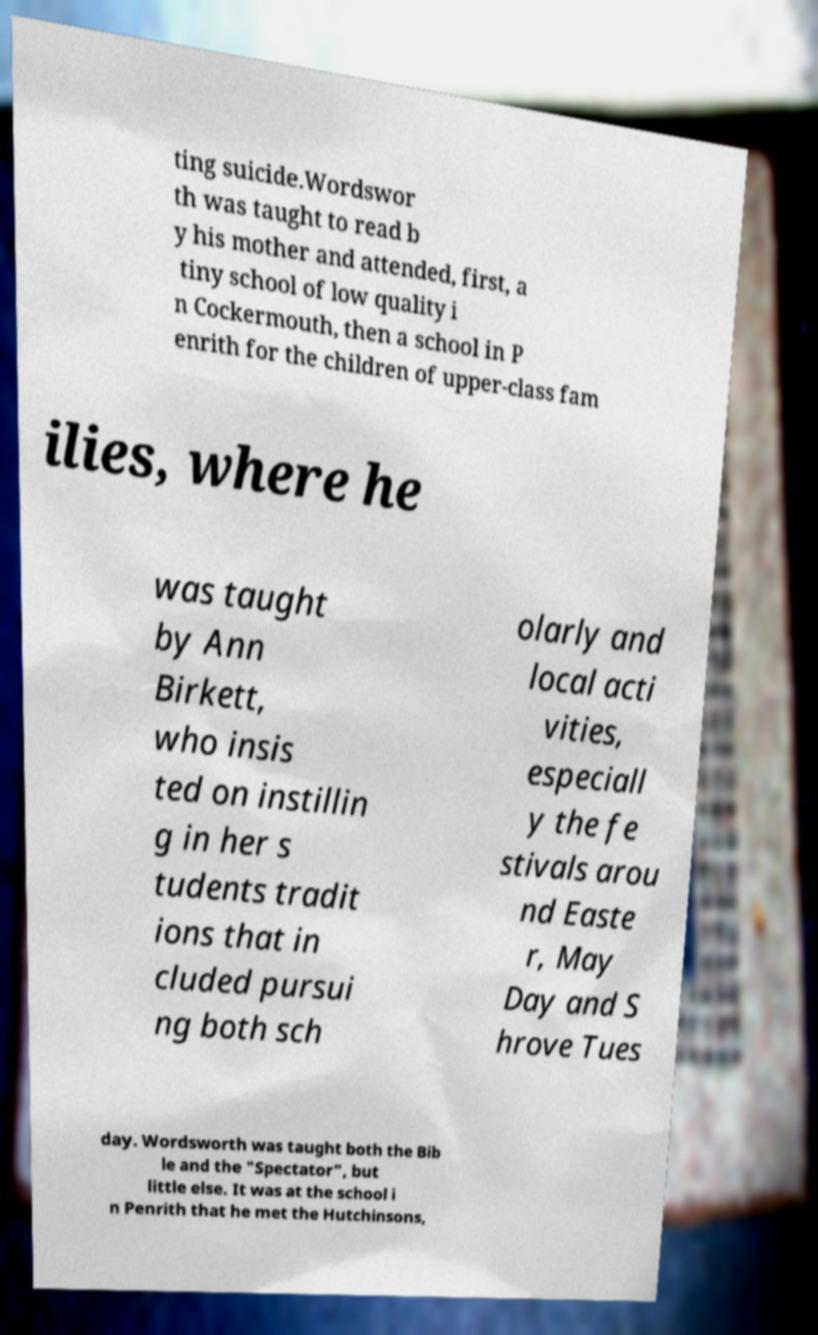Could you extract and type out the text from this image? ting suicide.Wordswor th was taught to read b y his mother and attended, first, a tiny school of low quality i n Cockermouth, then a school in P enrith for the children of upper-class fam ilies, where he was taught by Ann Birkett, who insis ted on instillin g in her s tudents tradit ions that in cluded pursui ng both sch olarly and local acti vities, especiall y the fe stivals arou nd Easte r, May Day and S hrove Tues day. Wordsworth was taught both the Bib le and the "Spectator", but little else. It was at the school i n Penrith that he met the Hutchinsons, 